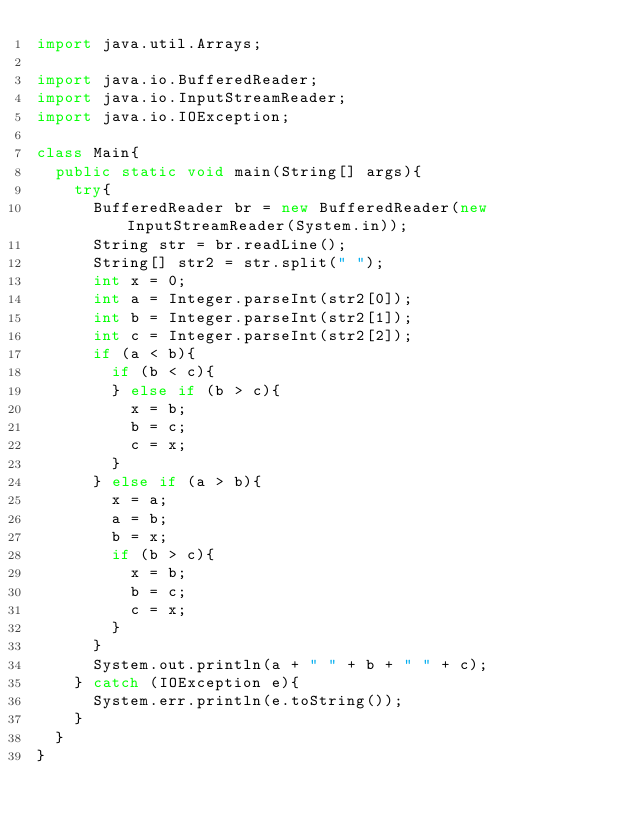<code> <loc_0><loc_0><loc_500><loc_500><_Java_>import java.util.Arrays;

import java.io.BufferedReader;
import java.io.InputStreamReader;
import java.io.IOException;

class Main{
  public static void main(String[] args){
    try{
      BufferedReader br = new BufferedReader(new InputStreamReader(System.in));
      String str = br.readLine();
      String[] str2 = str.split(" ");
      int x = 0;
      int a = Integer.parseInt(str2[0]);
      int b = Integer.parseInt(str2[1]);
      int c = Integer.parseInt(str2[2]);
      if (a < b){
        if (b < c){
        } else if (b > c){
          x = b;
          b = c;
          c = x;
        }
      } else if (a > b){
        x = a;
        a = b;
        b = x;
        if (b > c){
          x = b;
          b = c;
          c = x;
        }
      }
      System.out.println(a + " " + b + " " + c);
    } catch (IOException e){
      System.err.println(e.toString());
    }
  }
}
</code> 